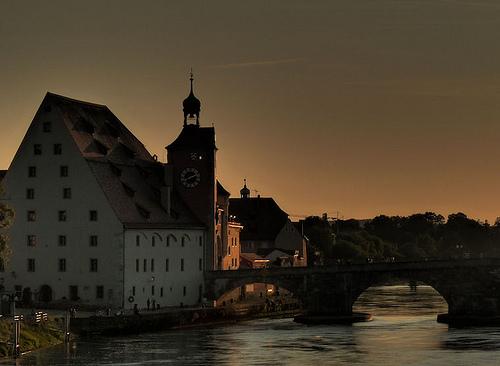How many windows does the house have?
Quick response, please. 35. How many stores is the building?
Concise answer only. 7. What is on the water?
Quick response, please. Bridge. What color is the roof of the building?
Answer briefly. Gray. Is there a kite in the air?
Keep it brief. No. How can you tell the time here?
Write a very short answer. Clock tower. What type of building is in the background?
Keep it brief. Church. Is it daytime?
Concise answer only. No. Is there a plane flying above the building?
Quick response, please. No. What city is this?
Concise answer only. London. 